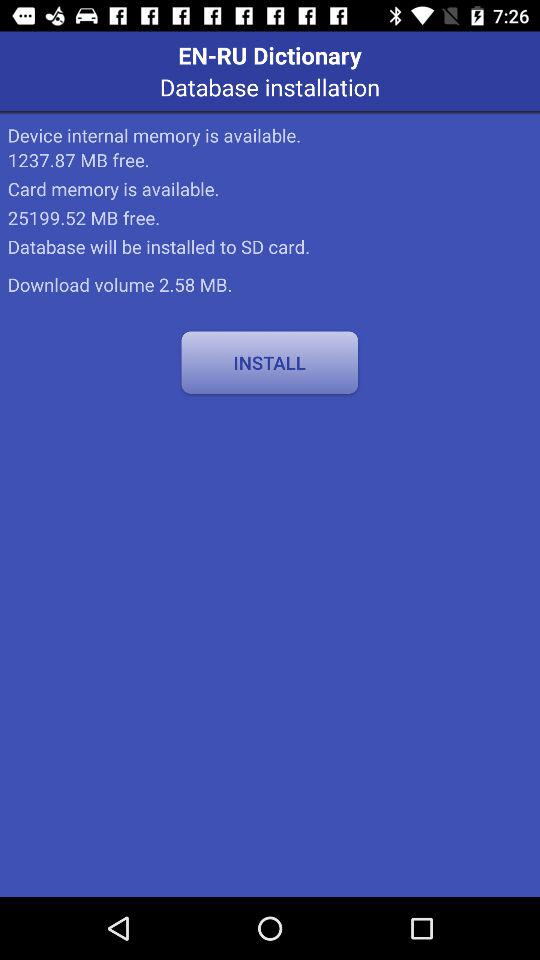How much more free space is there on the SD card than on the device's internal memory?
Answer the question using a single word or phrase. 23961.65 